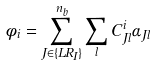Convert formula to latex. <formula><loc_0><loc_0><loc_500><loc_500>\phi _ { i } = \sum ^ { n _ { b } } _ { J \in \{ L R _ { I } \} } \sum _ { l } C _ { J l } ^ { i } \alpha _ { J l }</formula> 